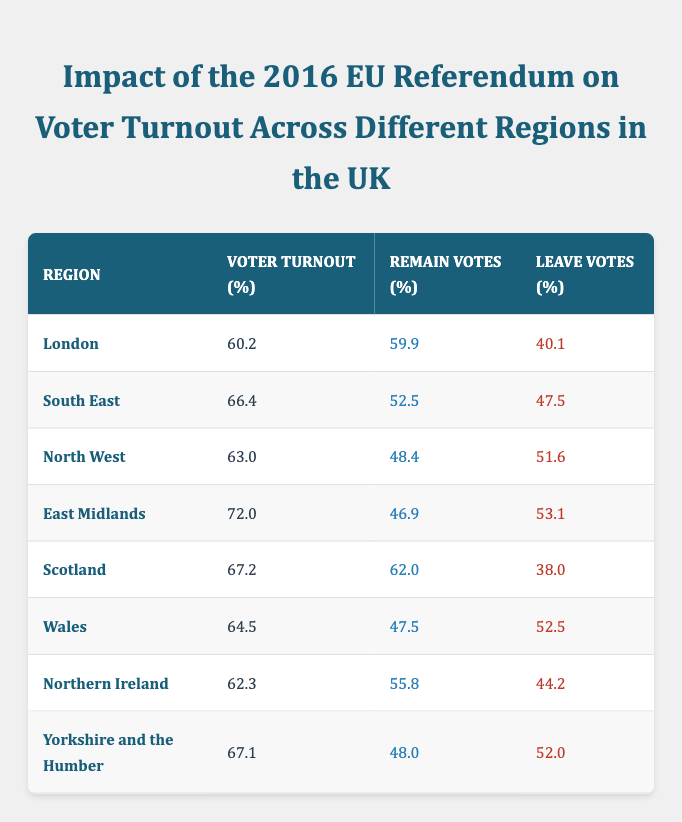What is the voter turnout percentage for Scotland? The table lists Scotland's voter turnout percentage as 67.2, which is the specific value indicated in the row for Scotland.
Answer: 67.2 Which region had the highest voter turnout? By comparing the voter turnout percentages listed for each region, East Midlands has the highest at 72.0.
Answer: East Midlands What is the percentage of leave votes in the North West? According to the table, the percentage of leave votes in the North West is specified as 51.6, directly extracted from the row pertaining to that region.
Answer: 51.6 What is the average voter turnout percentage across all regions? To find the average, add all voter turnout percentages: (60.2 + 66.4 + 63.0 + 72.0 + 67.2 + 64.5 + 62.3 + 67.1) = 422.7, then divide by 8 (the number of regions), resulting in an average of 52.8375.
Answer: 65.34 Is the percentage of remain votes in Wales greater than that in the South East? Wales has 47.5 remain votes, while South East has 52.5. Since 47.5 is less than 52.5, the statement is false.
Answer: No Which region has more leave votes than remain votes? Only the North West and East Midlands have more leave votes (51.6 and 53.1 respectively) than remain votes (48.4 and 46.9). North West and East Midlands fit this condition.
Answer: North West, East Midlands What is the difference between the highest and lowest voter turnout percentages? The highest is 72.0 (East Midlands) and the lowest is 60.2 (London). The difference is 72.0 - 60.2 = 11.8, showing the gap in voter turnout across regions.
Answer: 11.8 How many regions had a voter turnout below 65%? The regions with voter turnouts below 65% are London (60.2), Northern Ireland (62.3), and Wales (64.5), totaling three regions.
Answer: 3 